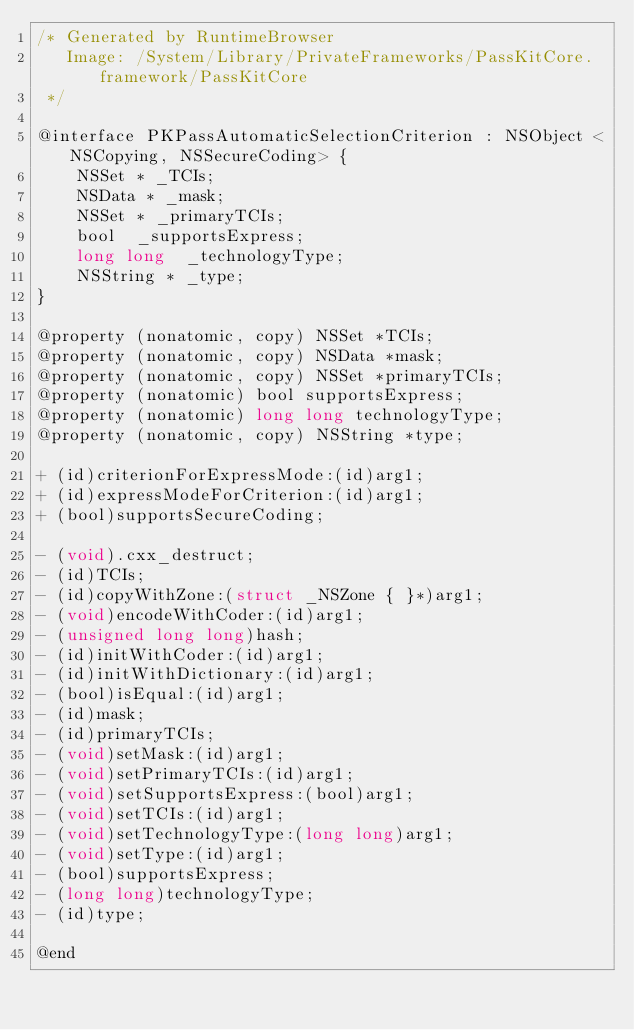<code> <loc_0><loc_0><loc_500><loc_500><_C_>/* Generated by RuntimeBrowser
   Image: /System/Library/PrivateFrameworks/PassKitCore.framework/PassKitCore
 */

@interface PKPassAutomaticSelectionCriterion : NSObject <NSCopying, NSSecureCoding> {
    NSSet * _TCIs;
    NSData * _mask;
    NSSet * _primaryTCIs;
    bool  _supportsExpress;
    long long  _technologyType;
    NSString * _type;
}

@property (nonatomic, copy) NSSet *TCIs;
@property (nonatomic, copy) NSData *mask;
@property (nonatomic, copy) NSSet *primaryTCIs;
@property (nonatomic) bool supportsExpress;
@property (nonatomic) long long technologyType;
@property (nonatomic, copy) NSString *type;

+ (id)criterionForExpressMode:(id)arg1;
+ (id)expressModeForCriterion:(id)arg1;
+ (bool)supportsSecureCoding;

- (void).cxx_destruct;
- (id)TCIs;
- (id)copyWithZone:(struct _NSZone { }*)arg1;
- (void)encodeWithCoder:(id)arg1;
- (unsigned long long)hash;
- (id)initWithCoder:(id)arg1;
- (id)initWithDictionary:(id)arg1;
- (bool)isEqual:(id)arg1;
- (id)mask;
- (id)primaryTCIs;
- (void)setMask:(id)arg1;
- (void)setPrimaryTCIs:(id)arg1;
- (void)setSupportsExpress:(bool)arg1;
- (void)setTCIs:(id)arg1;
- (void)setTechnologyType:(long long)arg1;
- (void)setType:(id)arg1;
- (bool)supportsExpress;
- (long long)technologyType;
- (id)type;

@end
</code> 